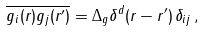<formula> <loc_0><loc_0><loc_500><loc_500>\overline { g _ { i } ( { r } ) g _ { j } ( { r ^ { \prime } } ) } = \Delta _ { g } \delta ^ { d } ( { r } - { r ^ { \prime } } ) \, \delta _ { i j } \, ,</formula> 